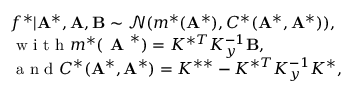Convert formula to latex. <formula><loc_0><loc_0><loc_500><loc_500>\begin{array} { r l } & { f ^ { * } | A ^ { * } , A , B \sim \mathcal { N } ( m ^ { * } ( A ^ { * } ) , C ^ { * } ( A ^ { * } , A ^ { * } ) ) , } \\ & { w i t h m ^ { * } ( A ^ { * } ) = K ^ { * T } K _ { y } ^ { - 1 } B , } \\ & { a n d C ^ { * } ( A ^ { * } , A ^ { * } ) = K ^ { * * } - K ^ { * T } K _ { y } ^ { - 1 } K ^ { * } , } \end{array}</formula> 